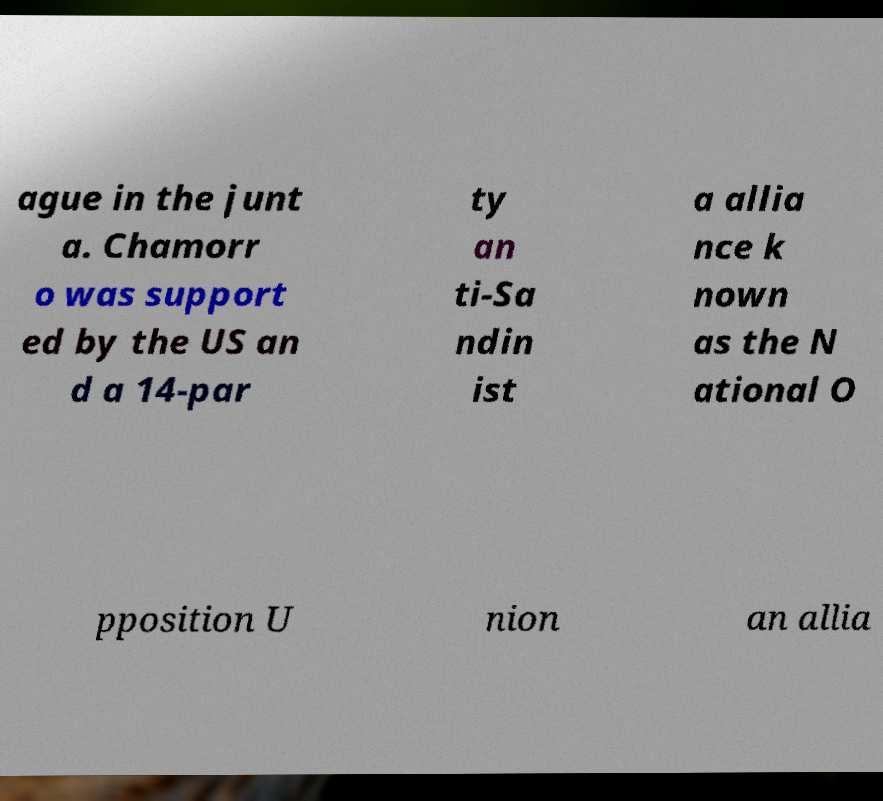I need the written content from this picture converted into text. Can you do that? ague in the junt a. Chamorr o was support ed by the US an d a 14-par ty an ti-Sa ndin ist a allia nce k nown as the N ational O pposition U nion an allia 